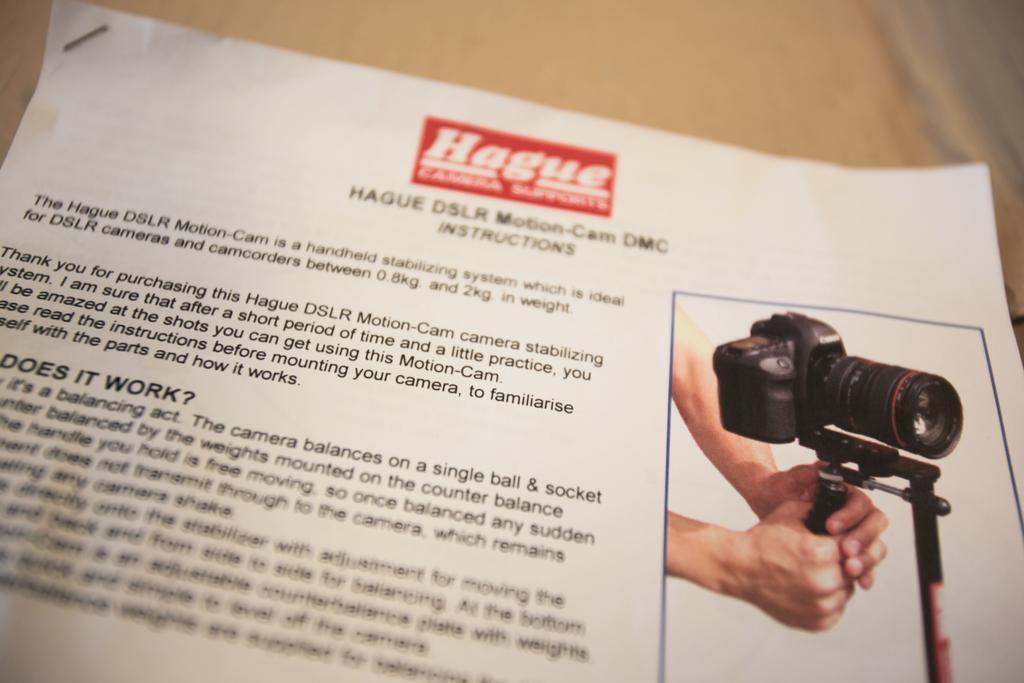How would you summarize this image in a sentence or two? It is a paper, on the right side there is an image, human is adjusting the camera. 